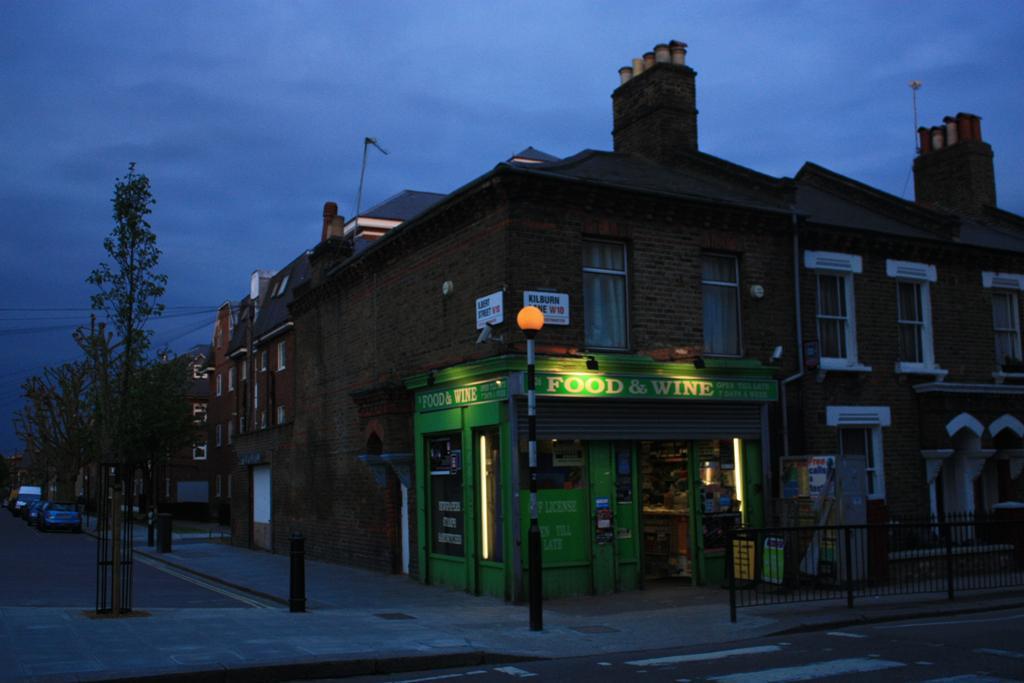How would you summarize this image in a sentence or two? These are the buildings with the windows. This looks like a store. I think this is a light pole. These are the barricades. I can see the trees. I think these are the cars, which are parked beside the road. Here is the sky. 